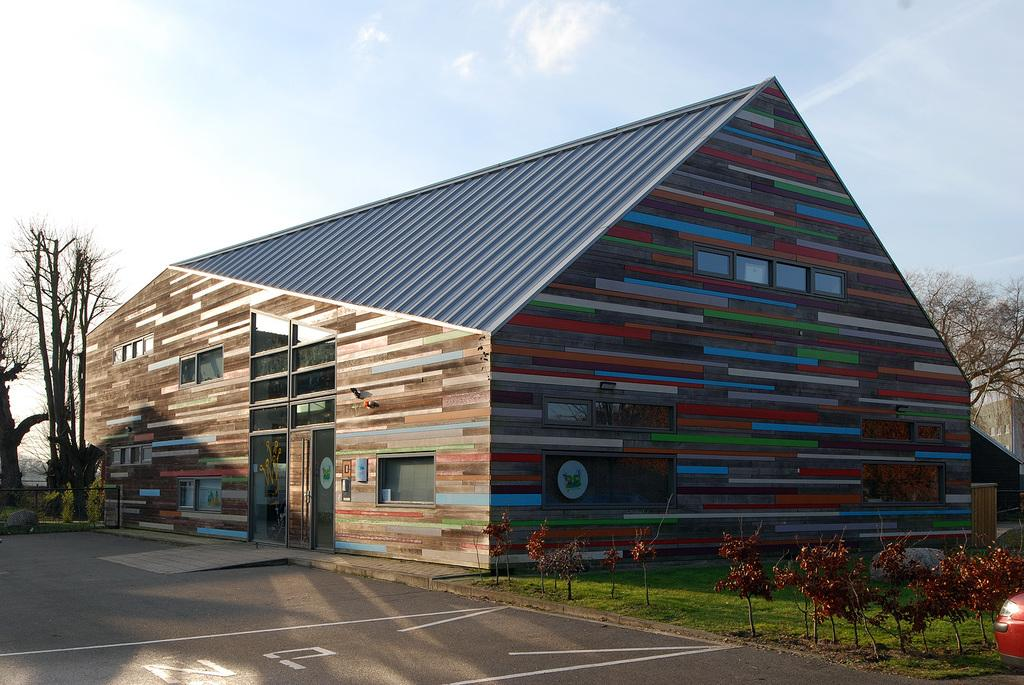What is the main subject in the center of the image? There is a house in the center of the image. What type of vegetation can be seen in the image? There are plants and trees in the image. What is located at the bottom of the image? There is a road at the bottom of the image. Can you tell me how many actors are present in the image? There are no actors present in the image; it features a house, plants, trees, and a road. 